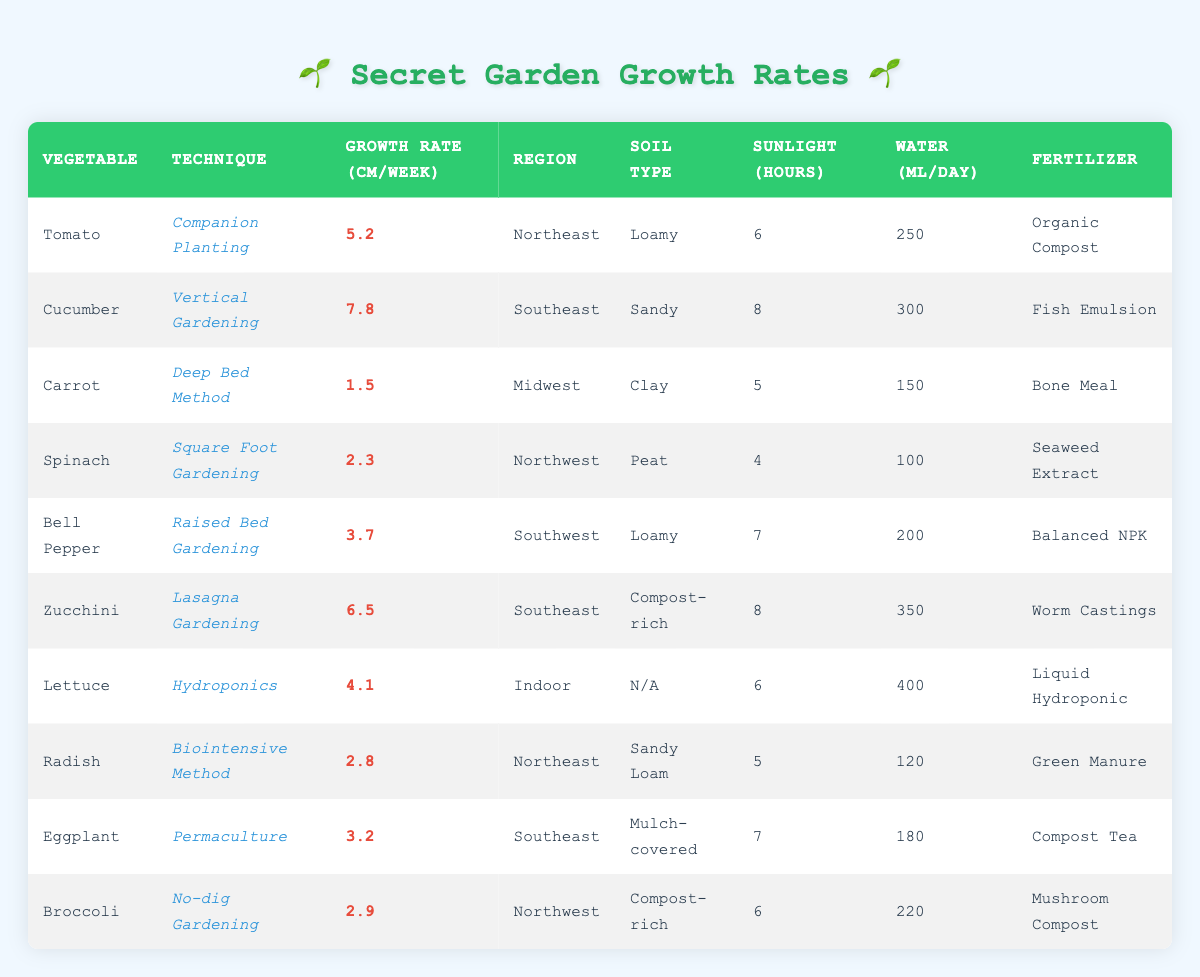What is the growth rate of Zucchini using Lasagna Gardening? The table directly lists the growth rate of Zucchini under the Lasagna Gardening technique as 6.5 cm per week.
Answer: 6.5 Which vegetable grows the fastest based on the data? To find the fastest-growing vegetable, we compare the growth rates listed in the table. Cucumber has the highest growth rate at 7.8 cm per week.
Answer: Cucumber How many vegetables have a growth rate greater than 4 cm per week? A close look at the growth rates shows that three vegetables exceed 4 cm: Cucumber (7.8), Zucchini (6.5), and Tomato (5.2), making a total of three.
Answer: 3 Is the statement "Eggplant has a higher growth rate than Broccoli" true? By checking the table, Eggplant has a growth rate of 3.2 cm per week, while Broccoli has a growth rate of 2.9 cm per week. Since 3.2 is greater than 2.9, the statement is true.
Answer: Yes What is the average growth rate for vegetables grown using techniques that involve gardening with soil? The vegetables grown with soil techniques include Tomato (5.2), Cucumber (7.8), Carrot (1.5), Spinach (2.3), Bell Pepper (3.7), Zucchini (6.5), Radish (2.8), Eggplant (3.2), and Broccoli (2.9). Summing these rates gives 36.0 cm; dividing by 9 (the number of vegetables) results in an average of 4.0 cm per week.
Answer: 4.0 Which technique yields the most sunlight for plant growth? The sunlight hours for each technique are listed. Vertical Gardening and Lasagna Gardening both have the maximum sunlight at 8 hours per day.
Answer: 8 hours How does the water requirement for Hydroponics compare with traditional soil techniques? Hydroponics requires 400 ml of water per day while traditional methods, for example, Companion Planting requires 250 ml. Thus Hydroponics requires 150 ml more per day than Companion Planting.
Answer: 150 ml more Are there any vegetables that grow in both loamy soil and rich compost? The table shows that both Tomato and Bell Pepper use loamy soil, while Zucchini and Broccoli use compost-rich soil. Tomato and Bell Pepper grow in loamy, so they do not grow in both kinds. Thus, the answer is no.
Answer: No Which region has the vegetable with the highest growth rate, and what is that rate? The region Southeast has Cucumber with the highest growth rate of 7.8 cm per week. This can be seen clearly in the table.
Answer: Southeast, 7.8 